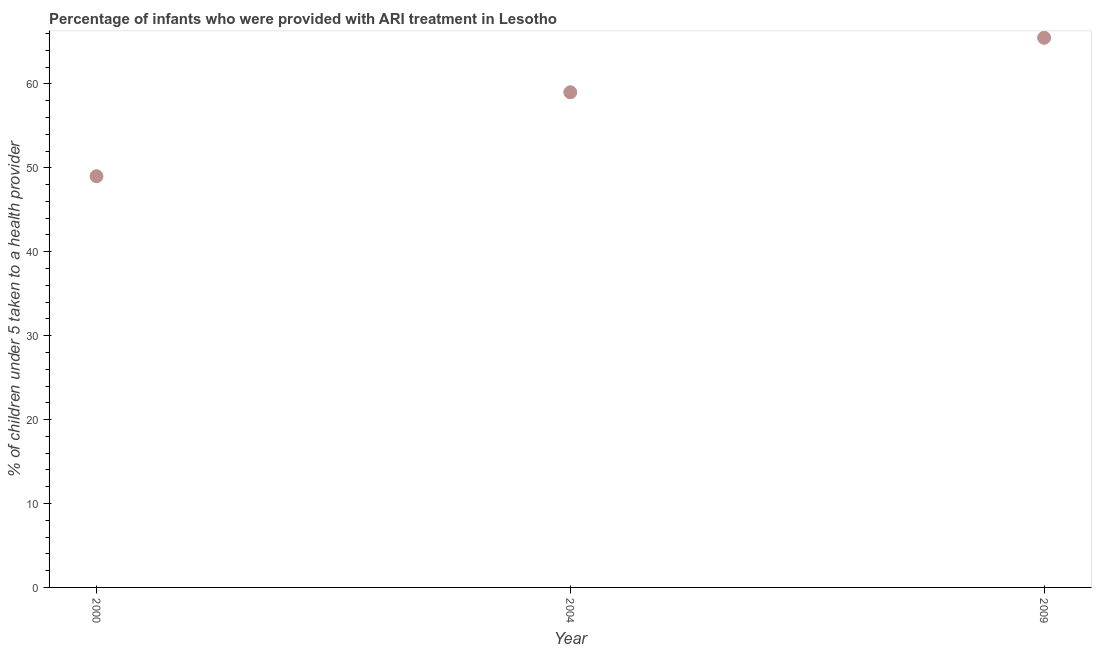What is the percentage of children who were provided with ari treatment in 2004?
Your answer should be very brief. 59. Across all years, what is the maximum percentage of children who were provided with ari treatment?
Your answer should be very brief. 65.5. In which year was the percentage of children who were provided with ari treatment maximum?
Give a very brief answer. 2009. What is the sum of the percentage of children who were provided with ari treatment?
Your answer should be compact. 173.5. What is the difference between the percentage of children who were provided with ari treatment in 2004 and 2009?
Give a very brief answer. -6.5. What is the average percentage of children who were provided with ari treatment per year?
Offer a terse response. 57.83. What is the median percentage of children who were provided with ari treatment?
Give a very brief answer. 59. In how many years, is the percentage of children who were provided with ari treatment greater than 32 %?
Provide a succinct answer. 3. Do a majority of the years between 2004 and 2000 (inclusive) have percentage of children who were provided with ari treatment greater than 30 %?
Keep it short and to the point. No. What is the ratio of the percentage of children who were provided with ari treatment in 2004 to that in 2009?
Give a very brief answer. 0.9. Is the percentage of children who were provided with ari treatment in 2004 less than that in 2009?
Offer a very short reply. Yes. Is the sum of the percentage of children who were provided with ari treatment in 2000 and 2004 greater than the maximum percentage of children who were provided with ari treatment across all years?
Give a very brief answer. Yes. What is the difference between the highest and the lowest percentage of children who were provided with ari treatment?
Give a very brief answer. 16.5. In how many years, is the percentage of children who were provided with ari treatment greater than the average percentage of children who were provided with ari treatment taken over all years?
Make the answer very short. 2. Does the percentage of children who were provided with ari treatment monotonically increase over the years?
Provide a succinct answer. Yes. How many dotlines are there?
Your answer should be compact. 1. How many years are there in the graph?
Ensure brevity in your answer.  3. Are the values on the major ticks of Y-axis written in scientific E-notation?
Keep it short and to the point. No. Does the graph contain any zero values?
Give a very brief answer. No. What is the title of the graph?
Give a very brief answer. Percentage of infants who were provided with ARI treatment in Lesotho. What is the label or title of the X-axis?
Your answer should be compact. Year. What is the label or title of the Y-axis?
Offer a very short reply. % of children under 5 taken to a health provider. What is the % of children under 5 taken to a health provider in 2009?
Your response must be concise. 65.5. What is the difference between the % of children under 5 taken to a health provider in 2000 and 2004?
Keep it short and to the point. -10. What is the difference between the % of children under 5 taken to a health provider in 2000 and 2009?
Provide a succinct answer. -16.5. What is the ratio of the % of children under 5 taken to a health provider in 2000 to that in 2004?
Offer a terse response. 0.83. What is the ratio of the % of children under 5 taken to a health provider in 2000 to that in 2009?
Your response must be concise. 0.75. What is the ratio of the % of children under 5 taken to a health provider in 2004 to that in 2009?
Provide a short and direct response. 0.9. 